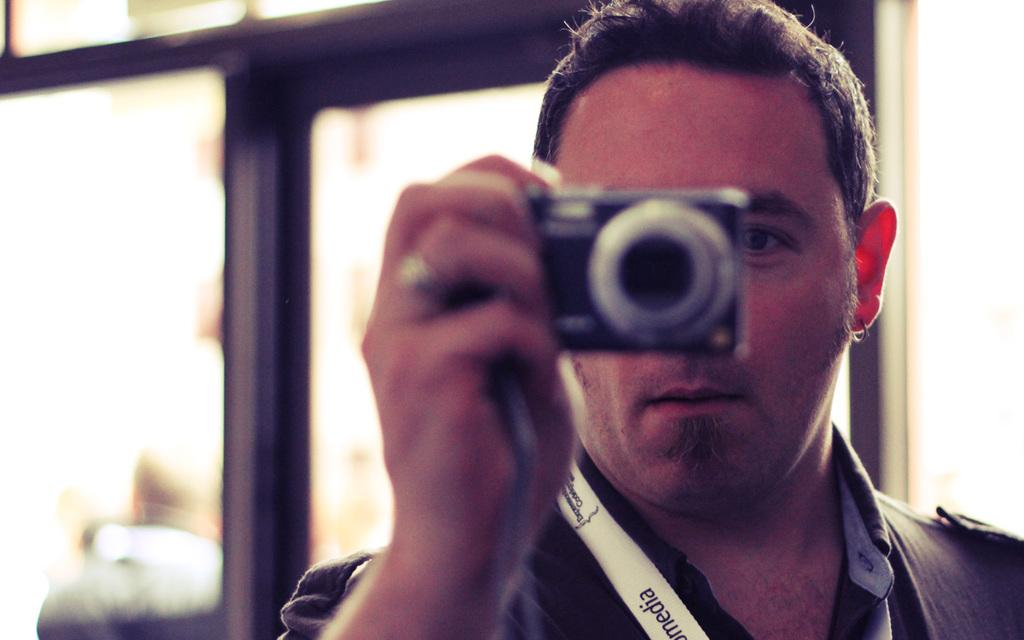Who is present in the image? There is a man in the image. What is the man wearing? The man is wearing a black shirt. What is the man holding in the image? The man is holding a camera. What can be seen in the background of the image? There is a glass window in the background of the image, and another person is visible through it. What else can be seen through the glass window? There is a wall visible through the glass window. How many fish can be seen swimming in the wilderness in the image? There are no fish or wilderness present in the image; it features a man holding a camera and a background with a glass window. 